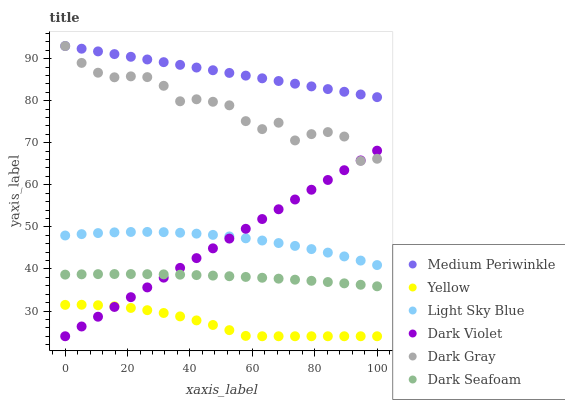Does Yellow have the minimum area under the curve?
Answer yes or no. Yes. Does Medium Periwinkle have the maximum area under the curve?
Answer yes or no. Yes. Does Dark Violet have the minimum area under the curve?
Answer yes or no. No. Does Dark Violet have the maximum area under the curve?
Answer yes or no. No. Is Dark Violet the smoothest?
Answer yes or no. Yes. Is Dark Gray the roughest?
Answer yes or no. Yes. Is Dark Gray the smoothest?
Answer yes or no. No. Is Dark Violet the roughest?
Answer yes or no. No. Does Dark Violet have the lowest value?
Answer yes or no. Yes. Does Dark Gray have the lowest value?
Answer yes or no. No. Does Dark Gray have the highest value?
Answer yes or no. Yes. Does Dark Violet have the highest value?
Answer yes or no. No. Is Dark Seafoam less than Medium Periwinkle?
Answer yes or no. Yes. Is Medium Periwinkle greater than Yellow?
Answer yes or no. Yes. Does Dark Violet intersect Light Sky Blue?
Answer yes or no. Yes. Is Dark Violet less than Light Sky Blue?
Answer yes or no. No. Is Dark Violet greater than Light Sky Blue?
Answer yes or no. No. Does Dark Seafoam intersect Medium Periwinkle?
Answer yes or no. No. 